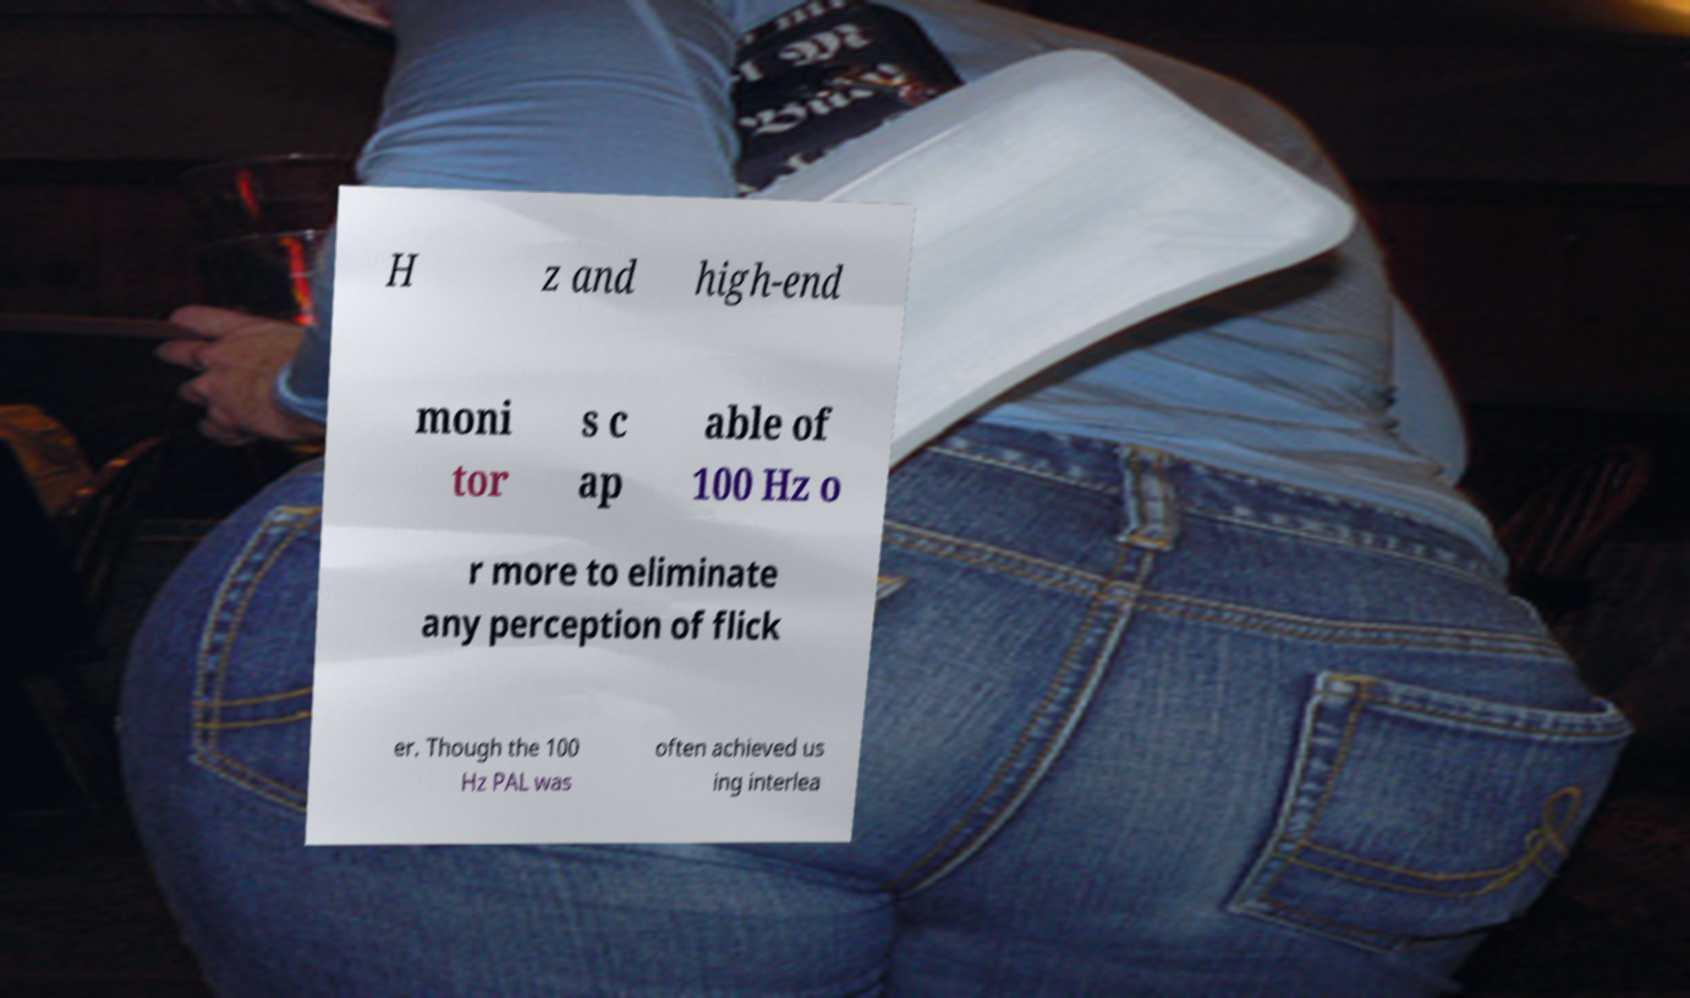What messages or text are displayed in this image? I need them in a readable, typed format. H z and high-end moni tor s c ap able of 100 Hz o r more to eliminate any perception of flick er. Though the 100 Hz PAL was often achieved us ing interlea 